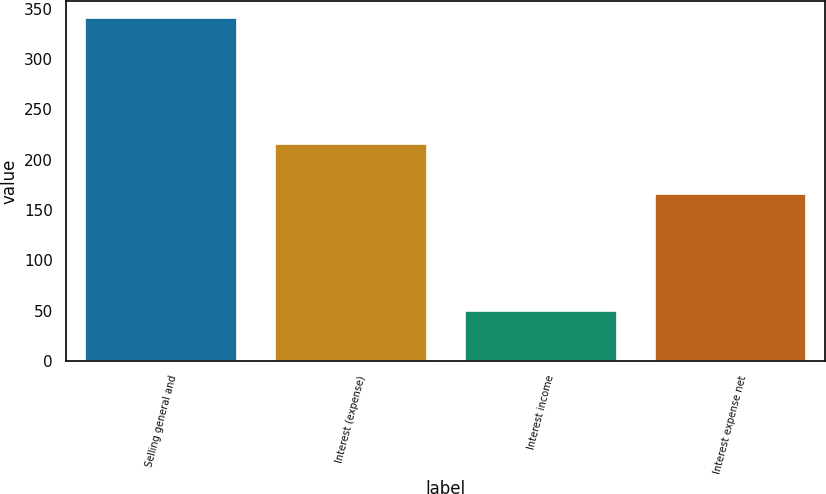<chart> <loc_0><loc_0><loc_500><loc_500><bar_chart><fcel>Selling general and<fcel>Interest (expense)<fcel>Interest income<fcel>Interest expense net<nl><fcel>341.1<fcel>215.8<fcel>49.7<fcel>166.1<nl></chart> 